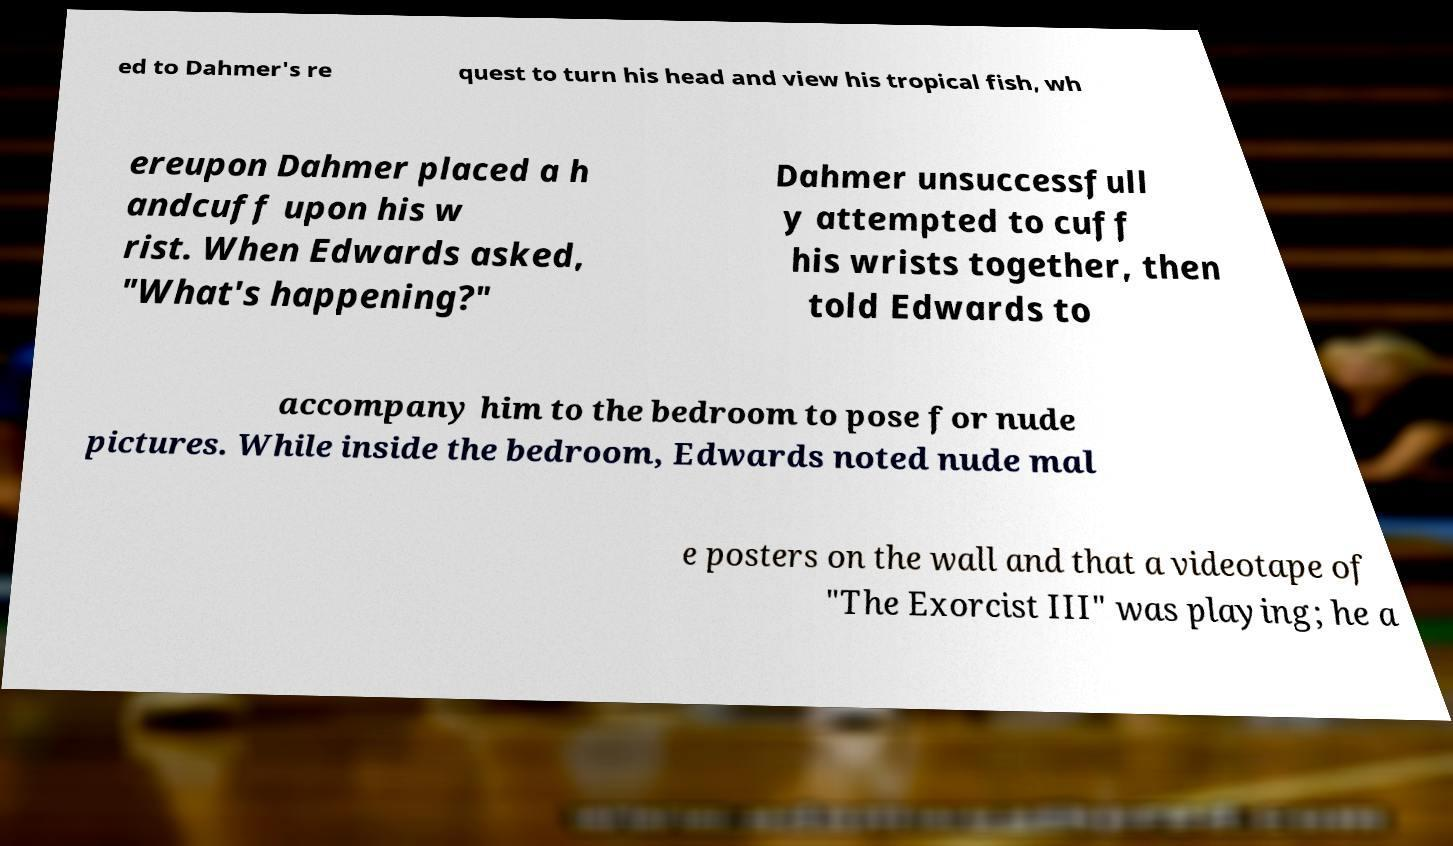Can you accurately transcribe the text from the provided image for me? ed to Dahmer's re quest to turn his head and view his tropical fish, wh ereupon Dahmer placed a h andcuff upon his w rist. When Edwards asked, "What's happening?" Dahmer unsuccessfull y attempted to cuff his wrists together, then told Edwards to accompany him to the bedroom to pose for nude pictures. While inside the bedroom, Edwards noted nude mal e posters on the wall and that a videotape of "The Exorcist III" was playing; he a 